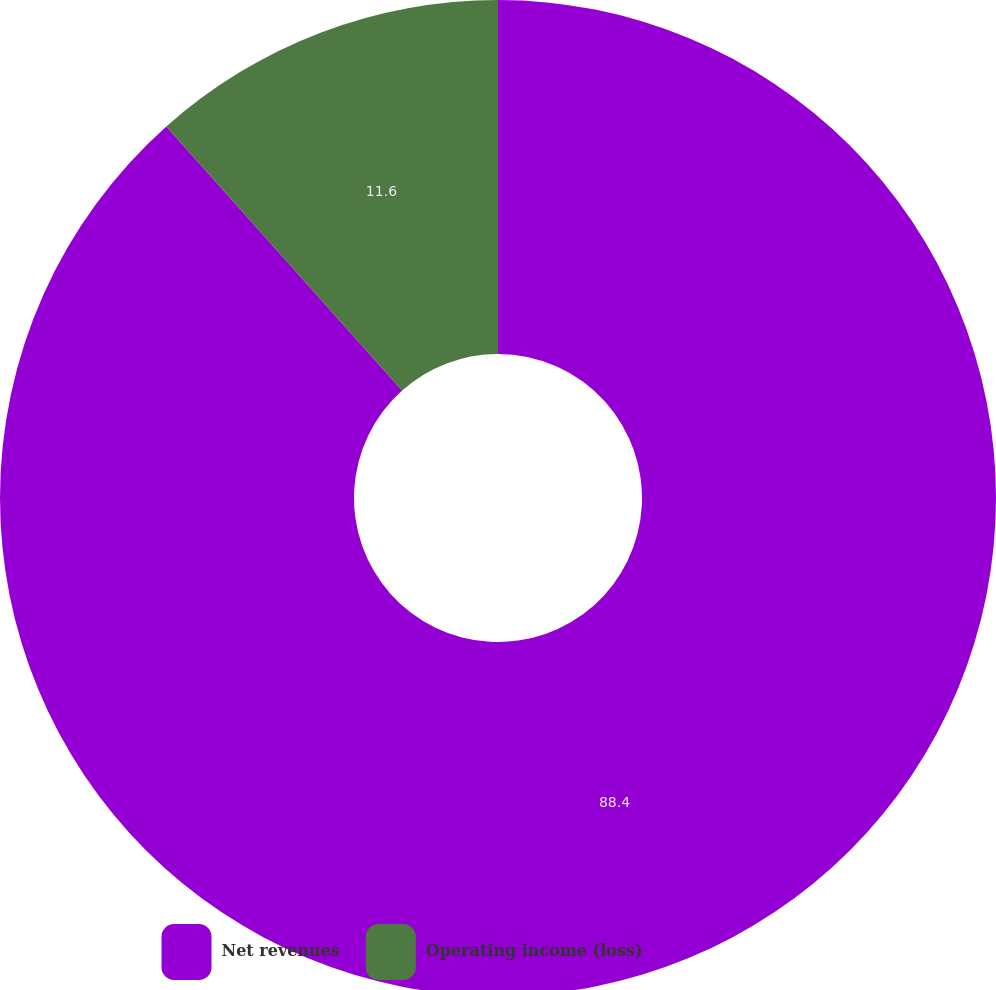Convert chart. <chart><loc_0><loc_0><loc_500><loc_500><pie_chart><fcel>Net revenues<fcel>Operating income (loss)<nl><fcel>88.4%<fcel>11.6%<nl></chart> 